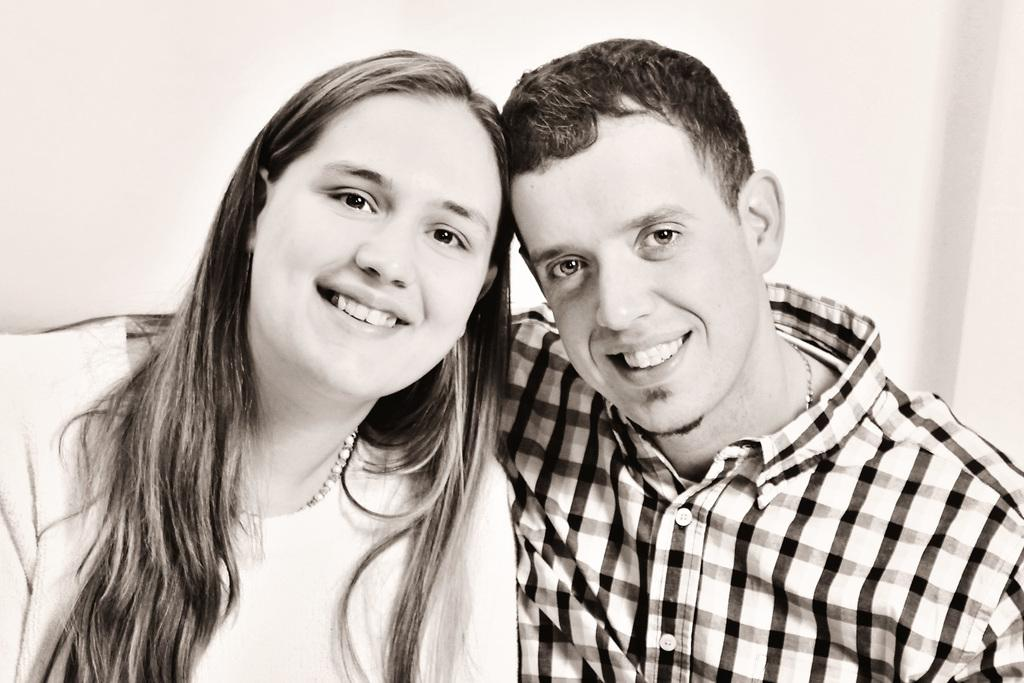What is the color scheme of the image? The image is black and white. How many people are in the image? There are two persons in the image. What are the persons doing in the image? The persons are sitting and smiling. What can be seen in the background of the image? There is a wall in the background of the image. What is the reason behind the acoustics of the hands in the image? There are no hands or acoustics mentioned in the image; it only features two persons sitting and smiling. 